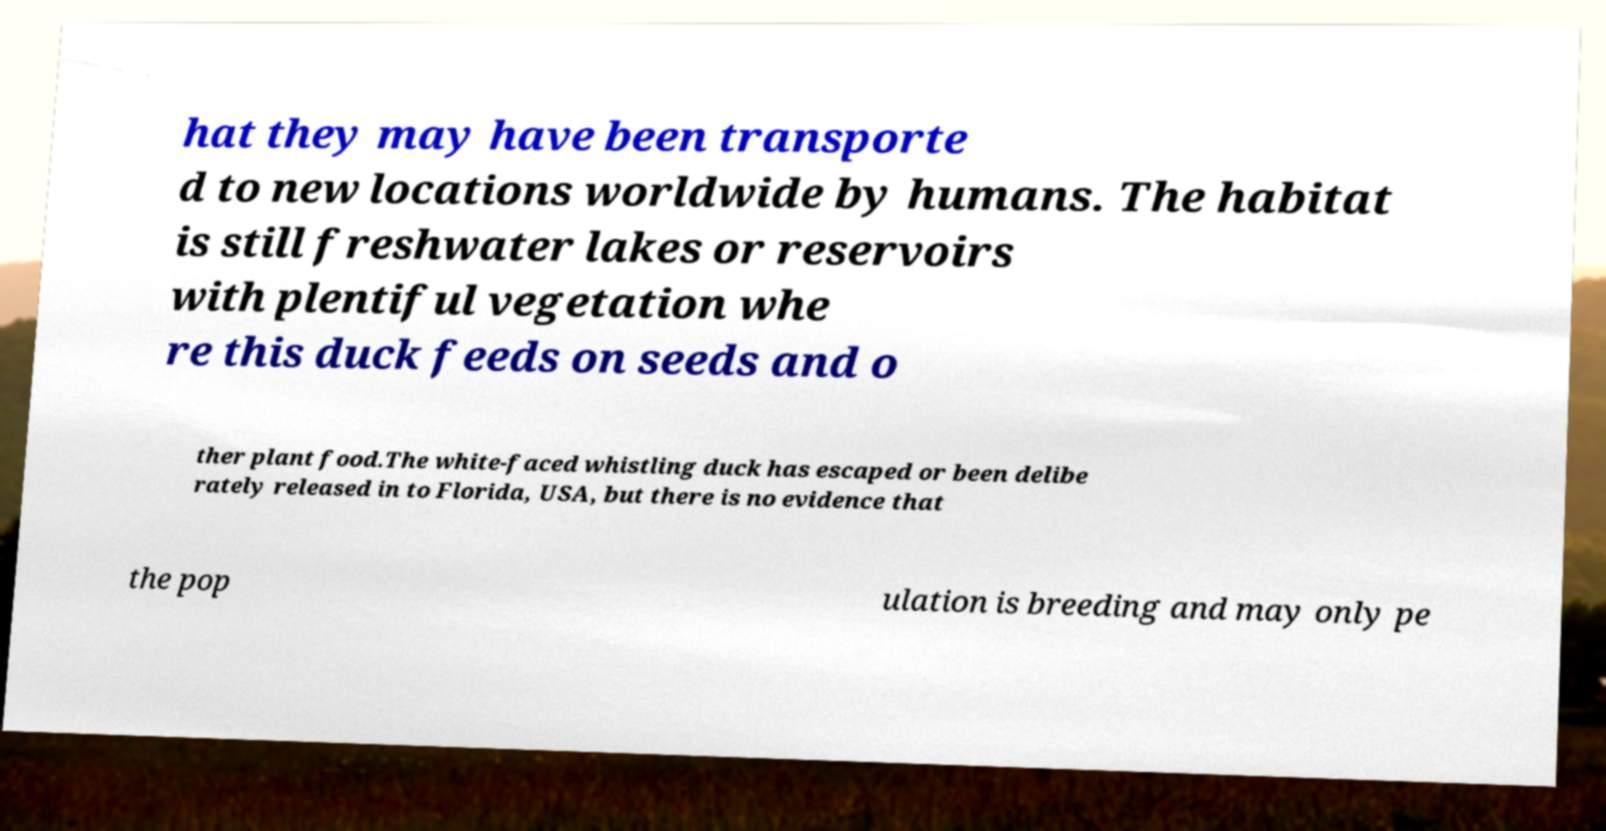What messages or text are displayed in this image? I need them in a readable, typed format. hat they may have been transporte d to new locations worldwide by humans. The habitat is still freshwater lakes or reservoirs with plentiful vegetation whe re this duck feeds on seeds and o ther plant food.The white-faced whistling duck has escaped or been delibe rately released in to Florida, USA, but there is no evidence that the pop ulation is breeding and may only pe 